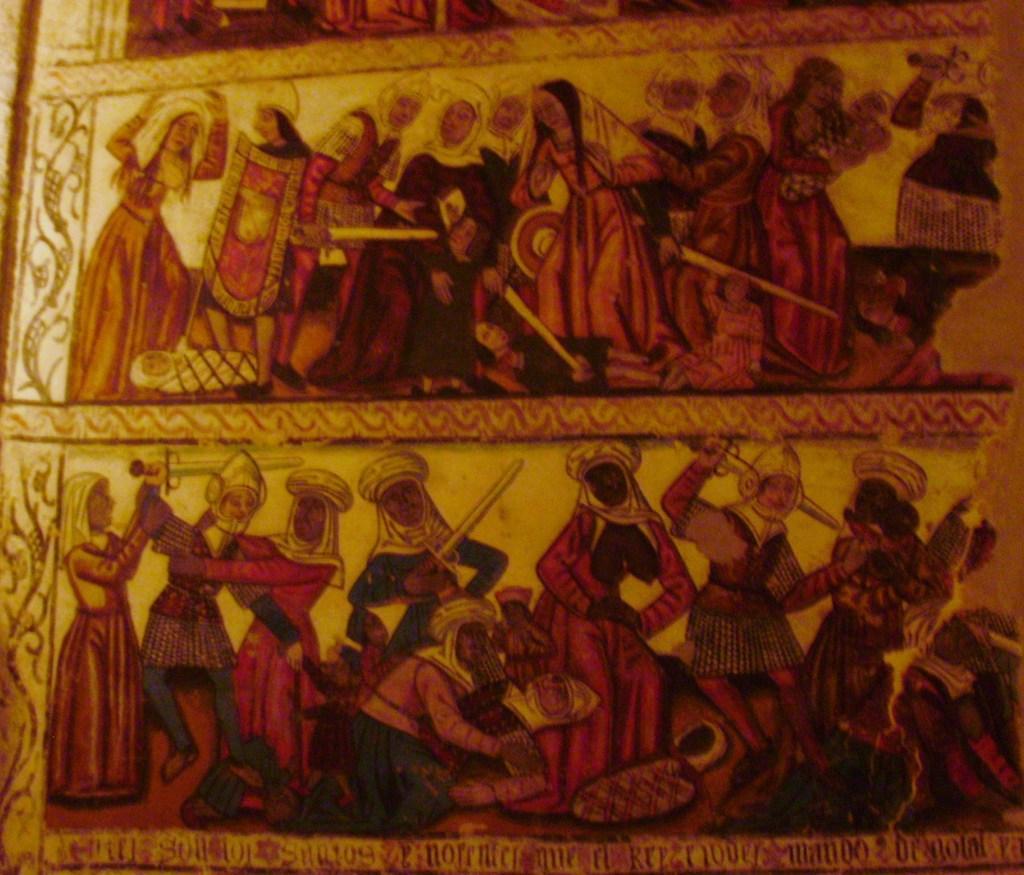Please provide a concise description of this image. In the picture I can see painting of people and some other things on an object. 